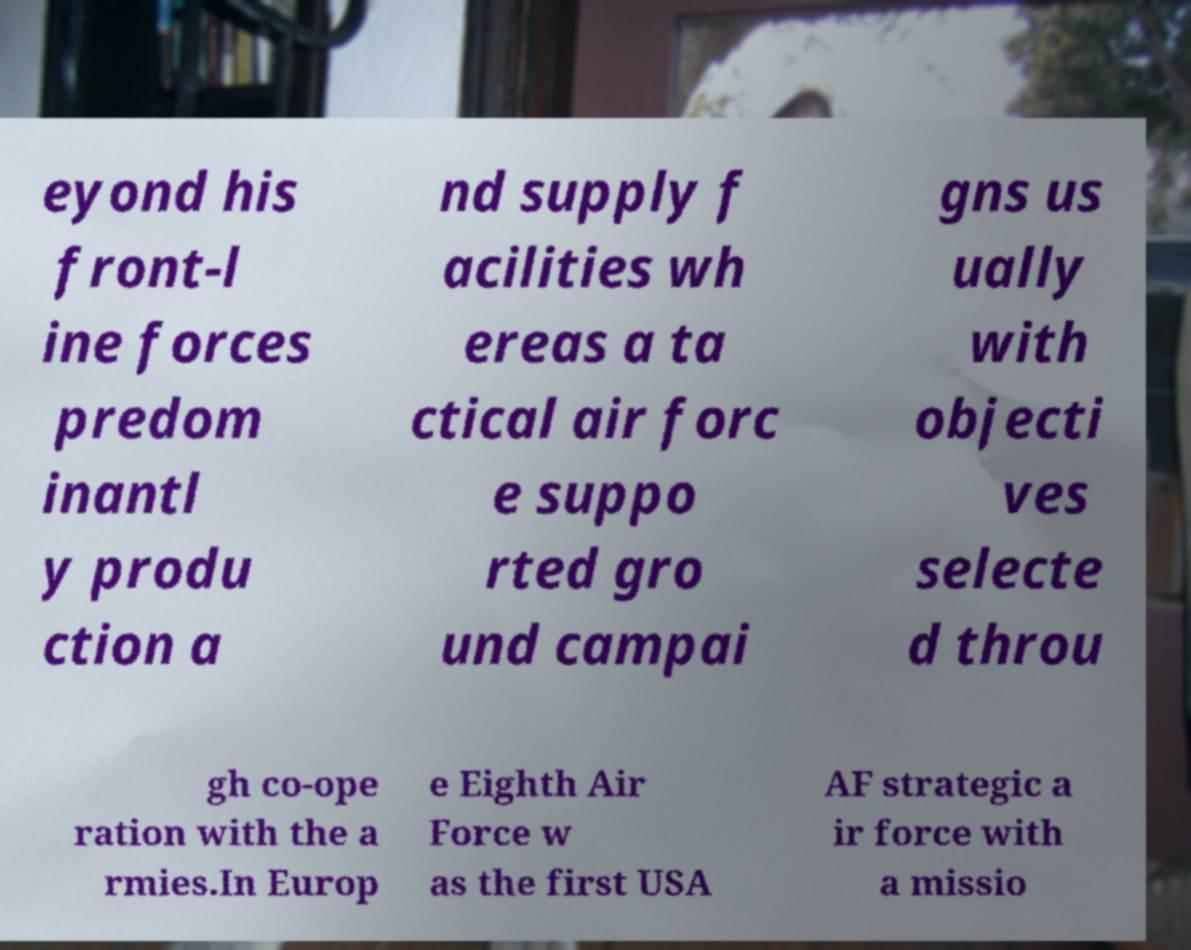Can you accurately transcribe the text from the provided image for me? eyond his front-l ine forces predom inantl y produ ction a nd supply f acilities wh ereas a ta ctical air forc e suppo rted gro und campai gns us ually with objecti ves selecte d throu gh co-ope ration with the a rmies.In Europ e Eighth Air Force w as the first USA AF strategic a ir force with a missio 